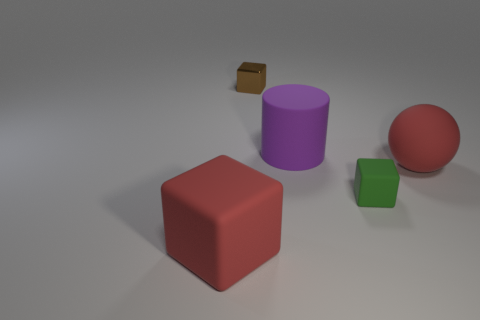Imagine these objects are part of a story. Can you create a short narrative involving them? In a quiet corner of a child's playroom, the red rubber ball dreams of rolling free in the sunshine, feeling the wind as it bounces along. The purple cylinder and green cube discuss their day, reminiscing about the creative structures they’ve been a part of. Hidden in the shadows, the brown box holds a secret treasure, waiting for the right moment to reveal its contents to the eager hands of the child. 